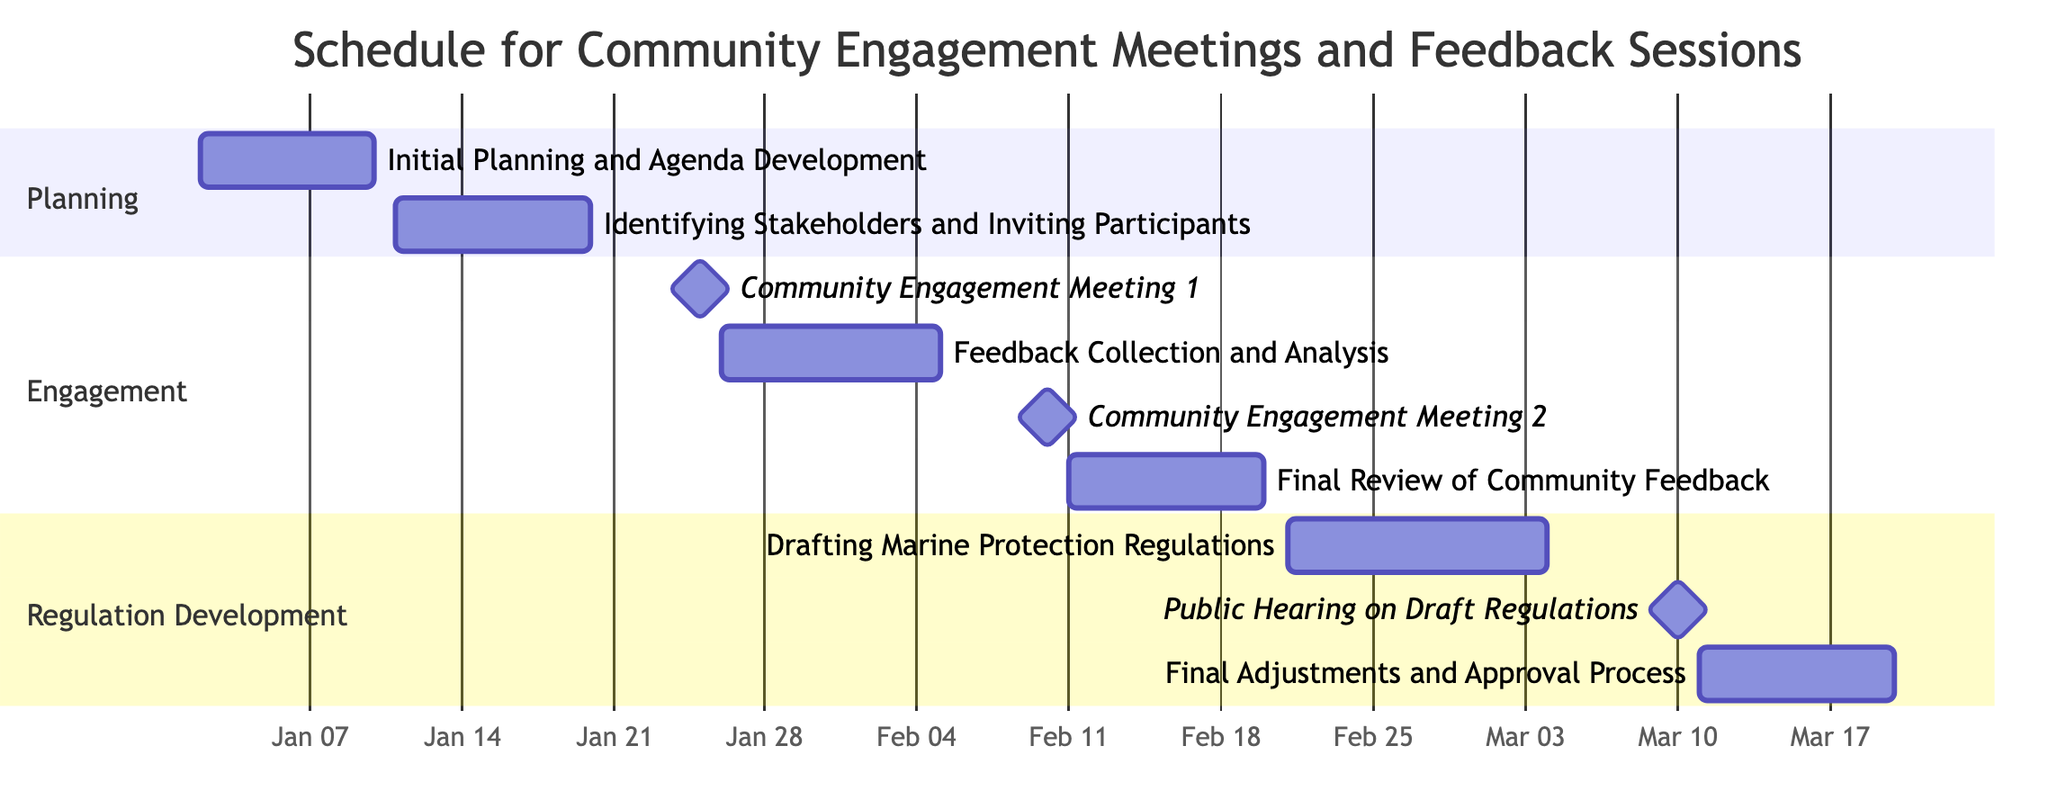What is the duration of the "Feedback Collection and Analysis" task? The task "Feedback Collection and Analysis" has a duration specified as 10 days in the diagram.
Answer: 10 days What are the start and end dates for "Community Engagement Meeting 2"? According to the diagram, "Community Engagement Meeting 2" begins on February 10, 2024, and ends on the same day, February 10, 2024.
Answer: February 10, 2024 How many days does the "Final Adjustments and Approval Process" take? The diagram indicates that the "Final Adjustments and Approval Process" lasts for 9 days, from March 11, 2024, to March 20, 2024.
Answer: 9 days Which task follows "Community Engagement Meeting 1"? After "Community Engagement Meeting 1," the following task is "Feedback Collection and Analysis," which starts the next day on January 26, 2024.
Answer: Feedback Collection and Analysis What are the milestones indicated in the diagram? The milestones shown in the diagram are "Community Engagement Meeting 1," "Community Engagement Meeting 2," and "Public Hearing on Draft Regulations," each of which occurs on specific single days as marked in the chart.
Answer: Community Engagement Meeting 1, Community Engagement Meeting 2, Public Hearing on Draft Regulations What is the total planning phase duration? The planning phase consists of two tasks: "Initial Planning and Agenda Development" (8 days) and "Identifying Stakeholders and Inviting Participants" (9 days). Summing these gives a total of 17 days for the planning phase.
Answer: 17 days When does the drafting of the regulations begin? The "Drafting Marine Protection Regulations" task starts on February 21, 2024, as indicated in the diagram.
Answer: February 21, 2024 How many days are between "Community Engagement Meeting 1" and "Feedback Collection and Analysis"? "Community Engagement Meeting 1" ends on January 25, 2024, and "Feedback Collection and Analysis" starts the next day on January 26, 2024, which means there are no days in between them.
Answer: 0 days 